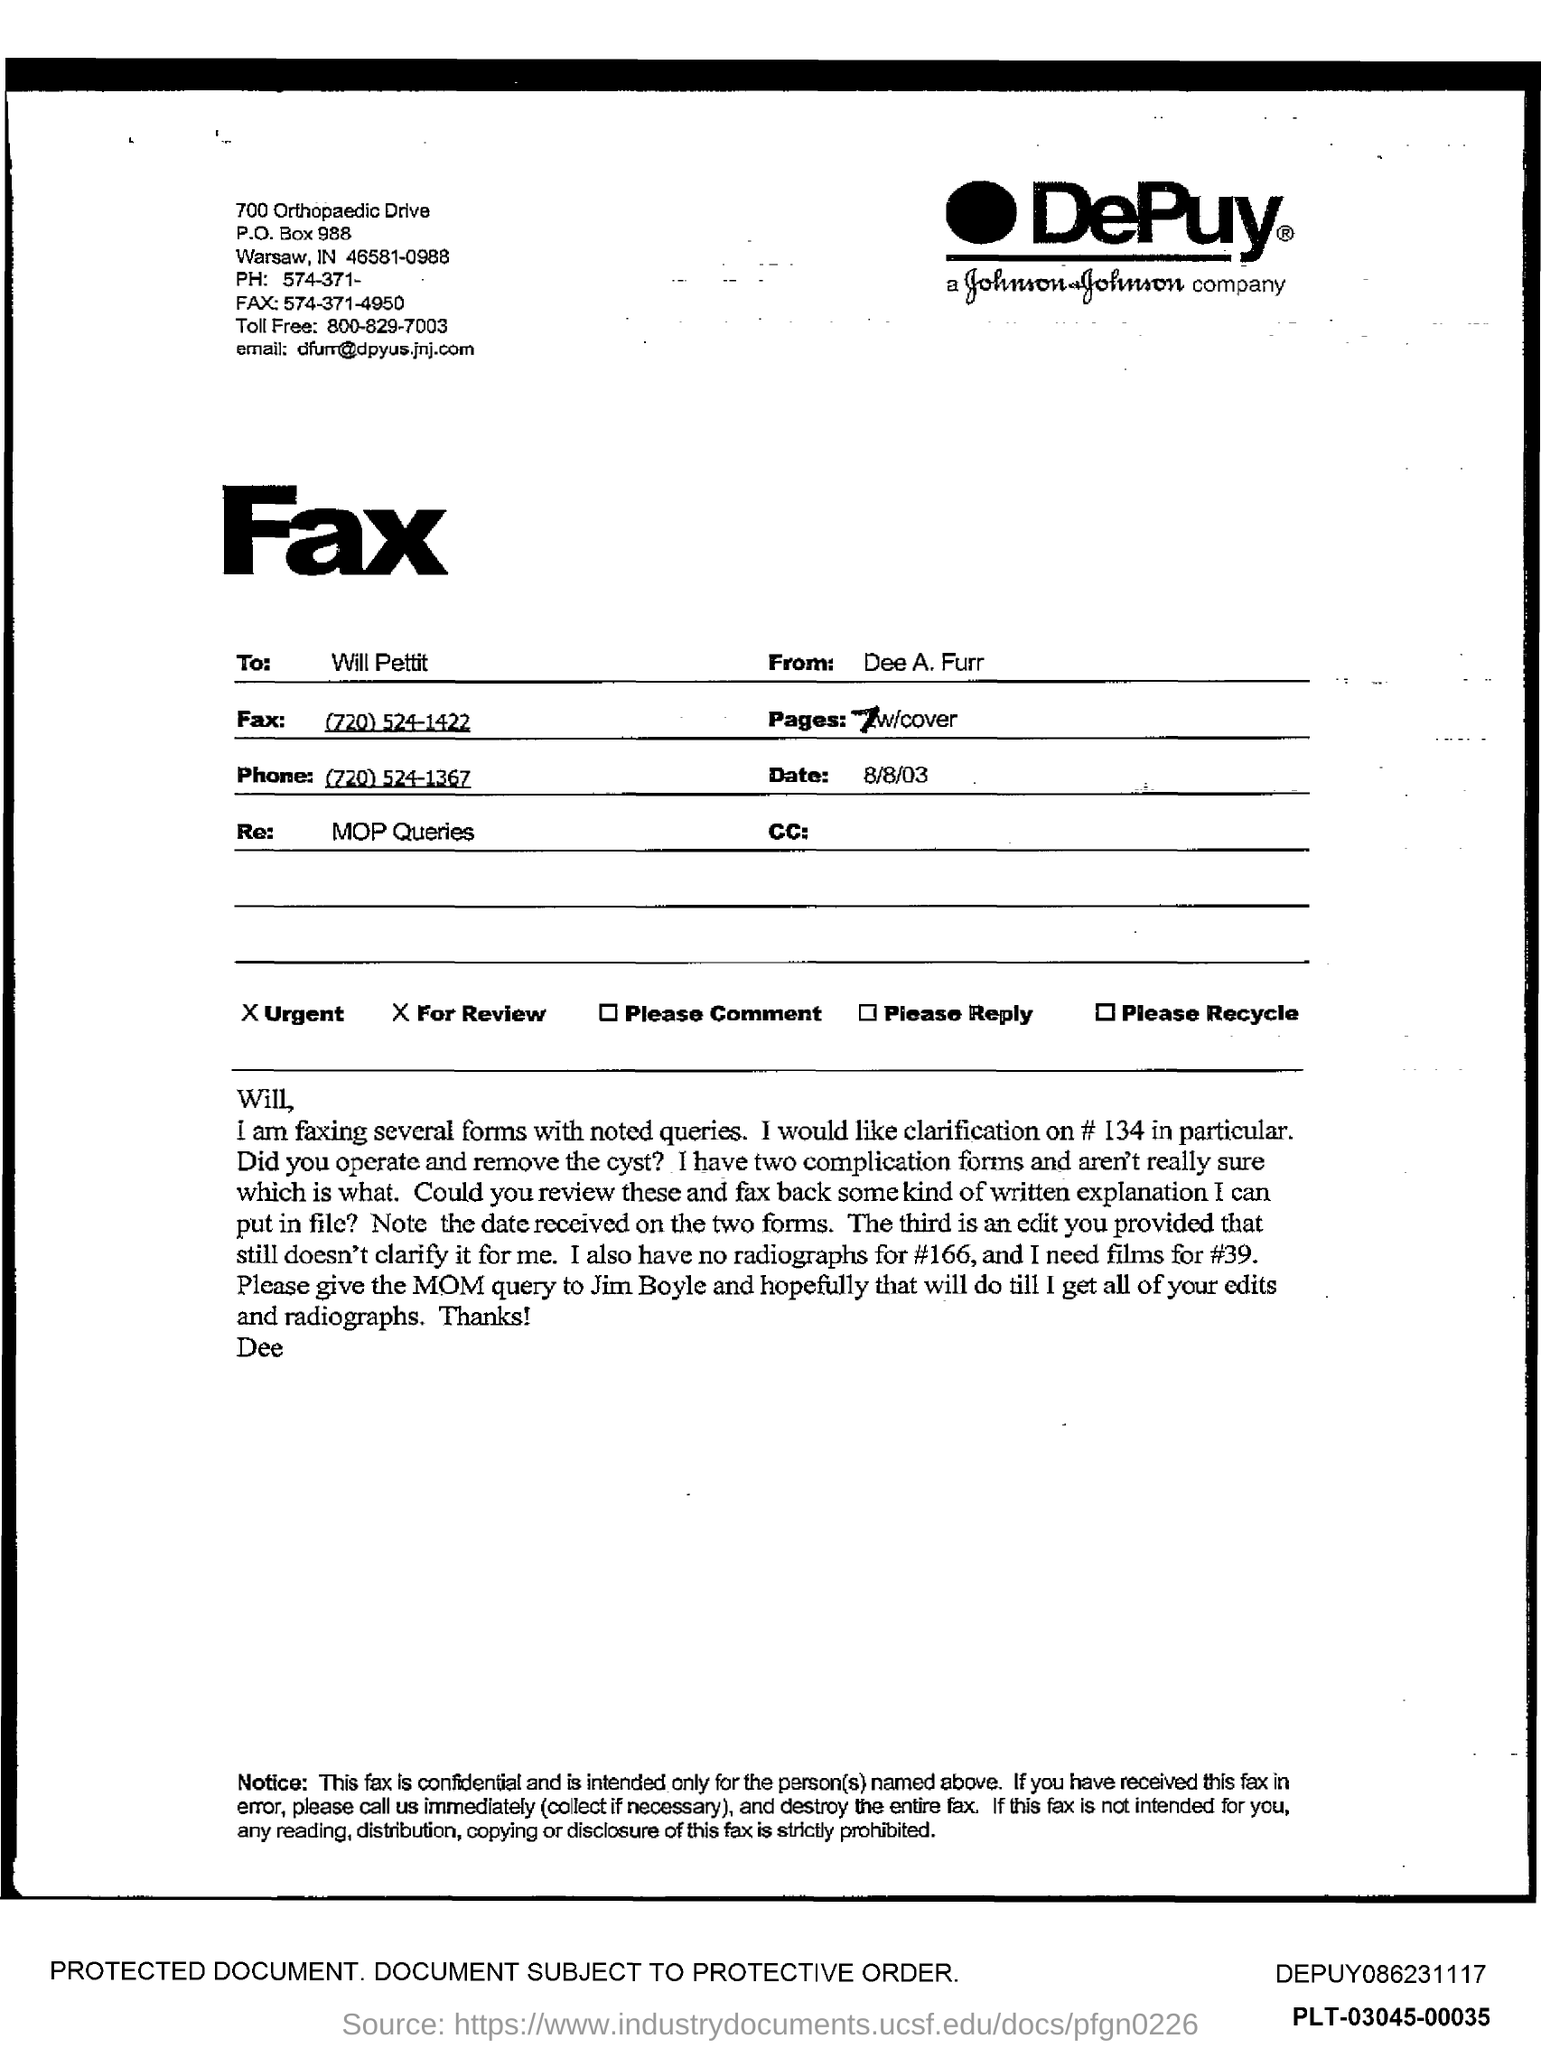To Whom is this Fax addressed to?
Your answer should be very brief. Will Pettit. Who is this Fax from?
Keep it short and to the point. Dee A. Furr. What is the Phone?
Make the answer very short. (720) 524-1367. What is the Fax?
Make the answer very short. (720) 524-1422. What is the Date?
Keep it short and to the point. 8/8/03. What is the Re:?
Offer a terse response. MOP Queries. 